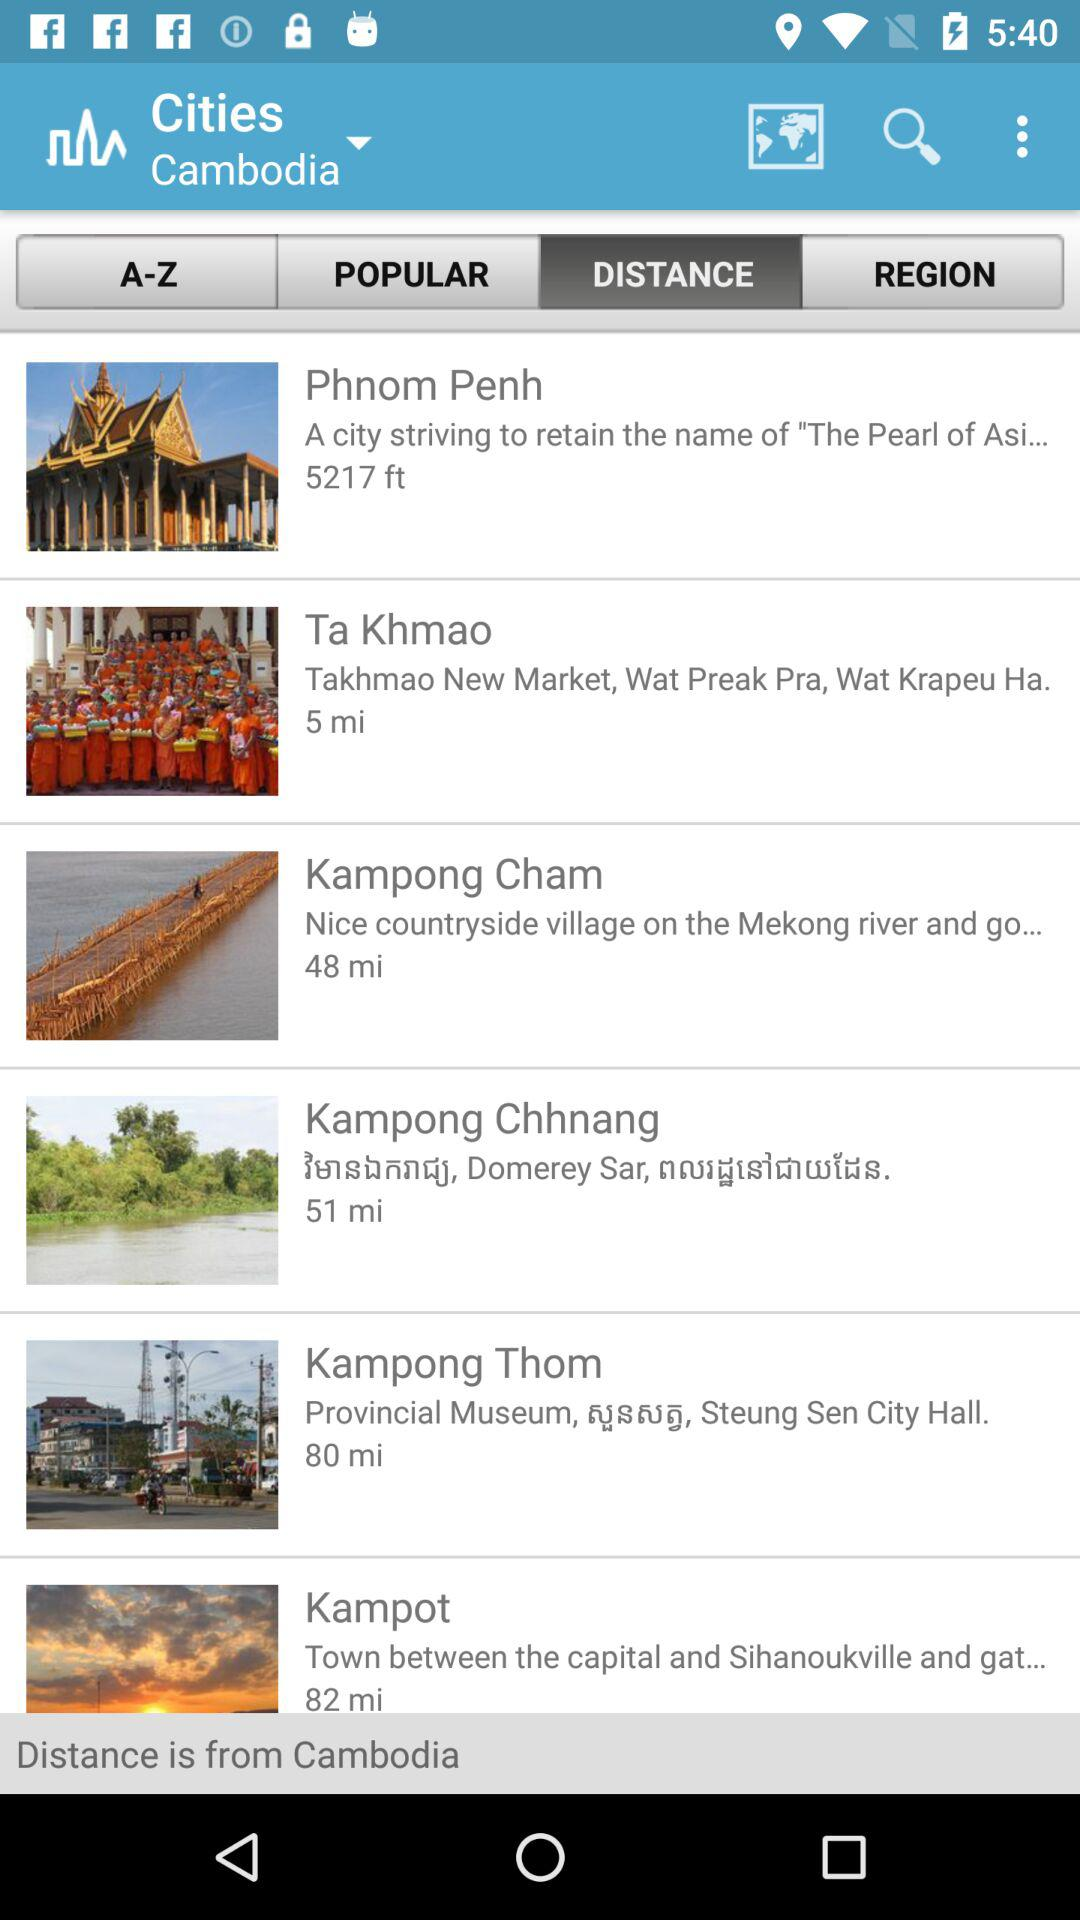What is the distance to Kampong Cham? The distance is 48 miles. 